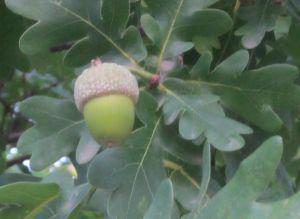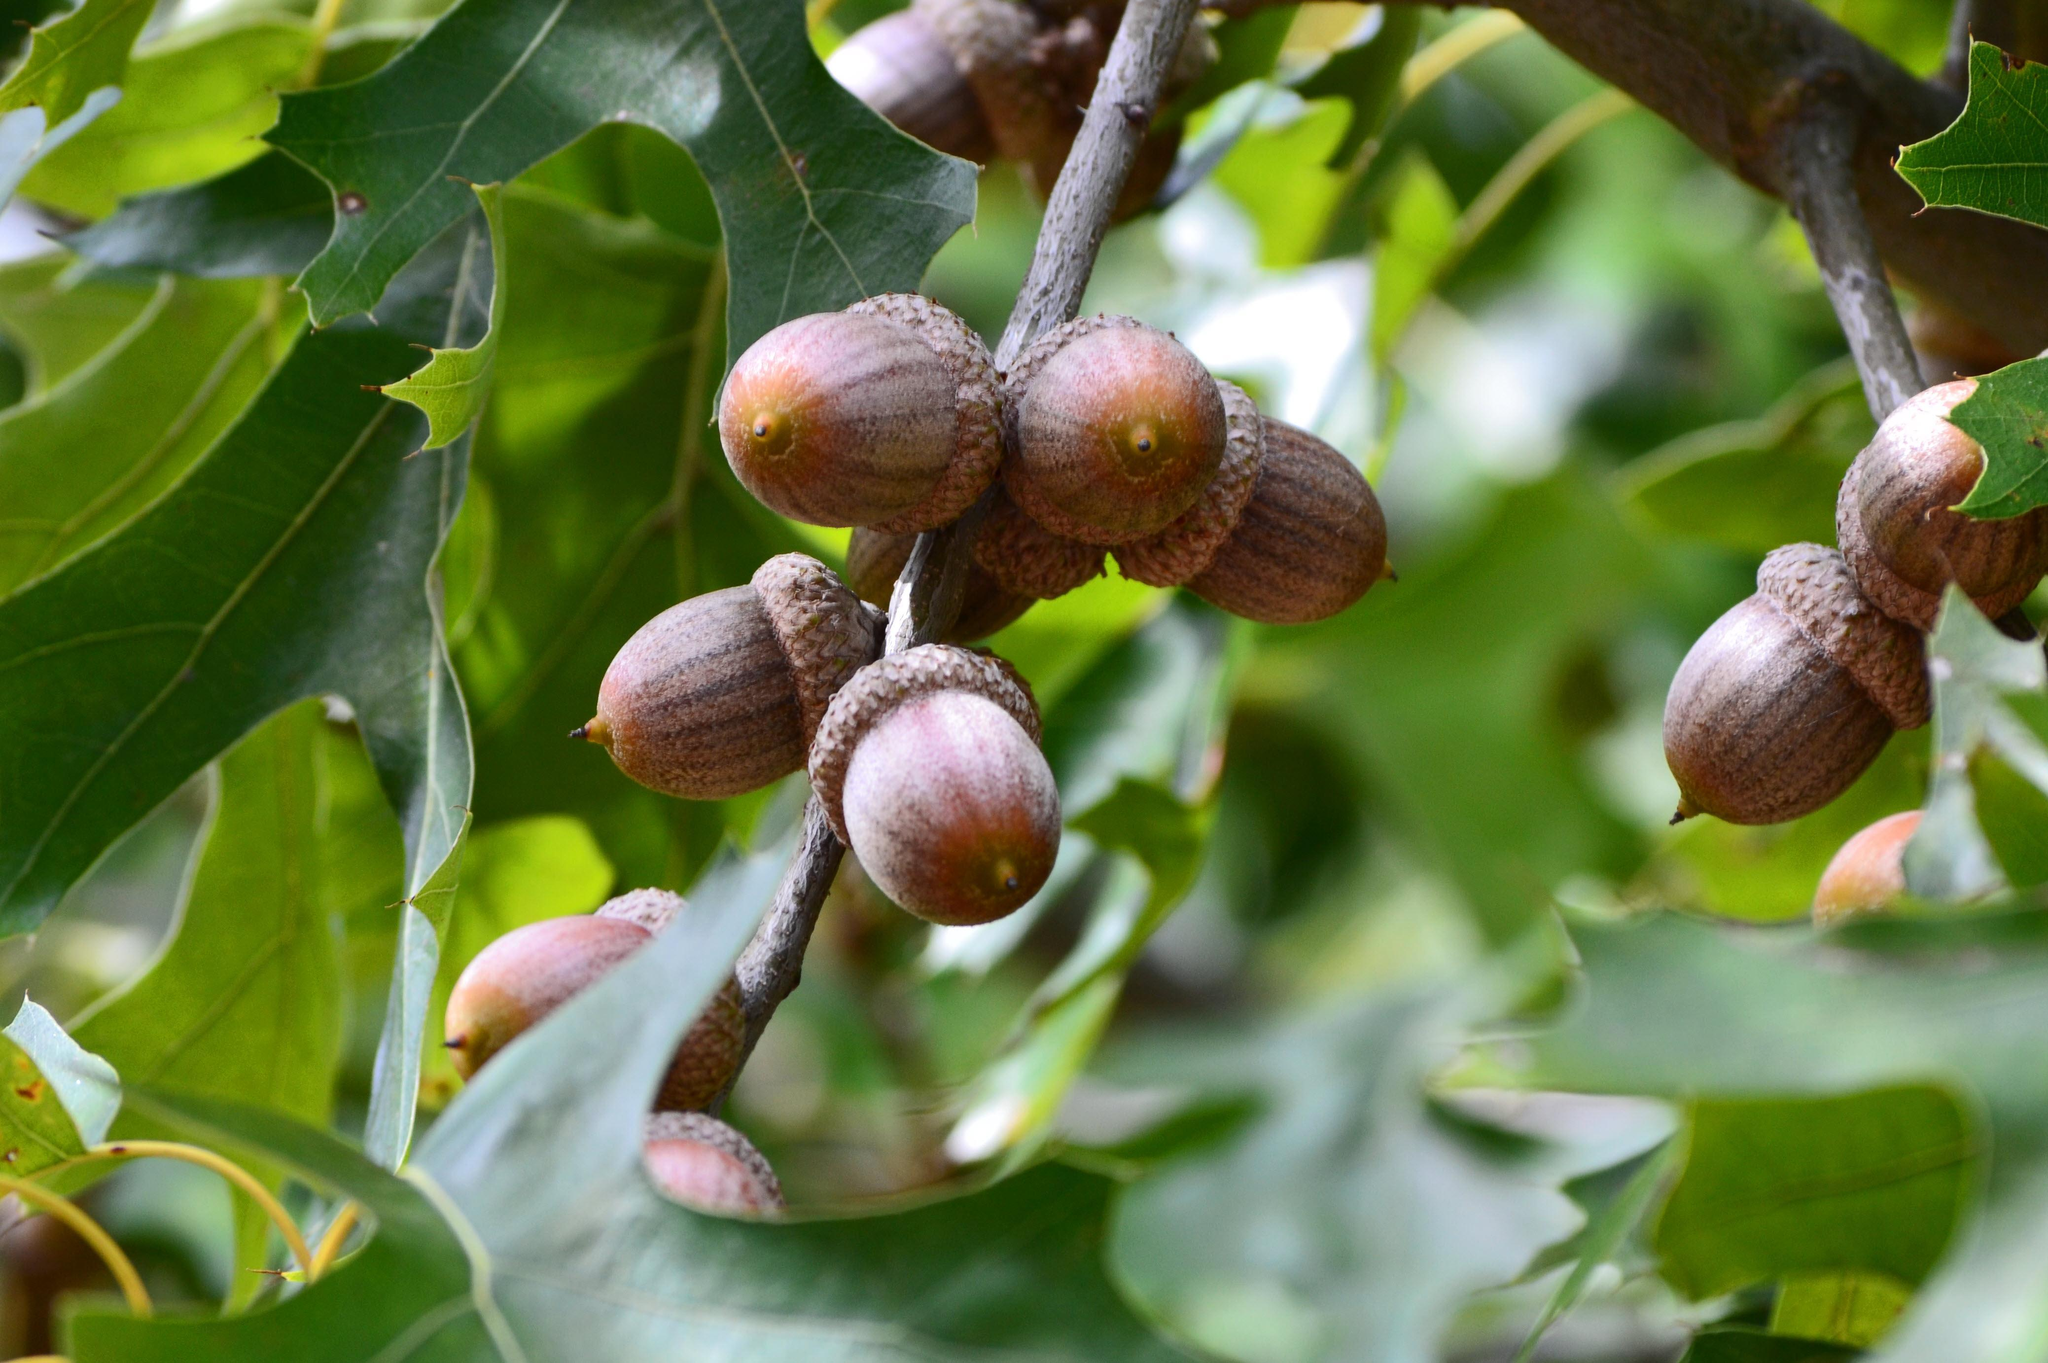The first image is the image on the left, the second image is the image on the right. For the images shown, is this caption "One image shows a single acorn attached to an oak tree." true? Answer yes or no. Yes. The first image is the image on the left, the second image is the image on the right. For the images displayed, is the sentence "The left image contains only acorns that are green, and the right image contains only acorns that are brown." factually correct? Answer yes or no. Yes. 